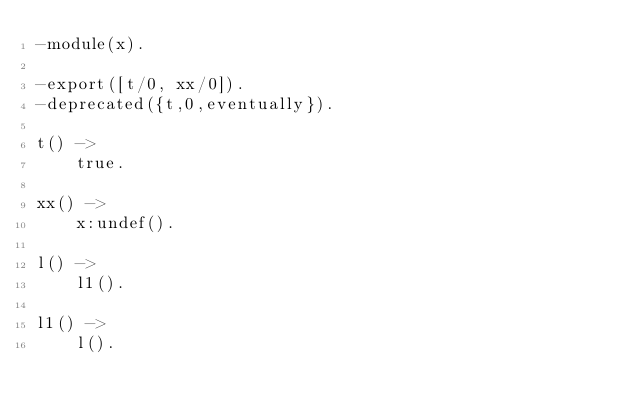<code> <loc_0><loc_0><loc_500><loc_500><_Erlang_>-module(x).

-export([t/0, xx/0]).
-deprecated({t,0,eventually}).

t() ->
    true.

xx() ->
    x:undef().

l() ->
    l1().

l1() ->
    l().
</code> 